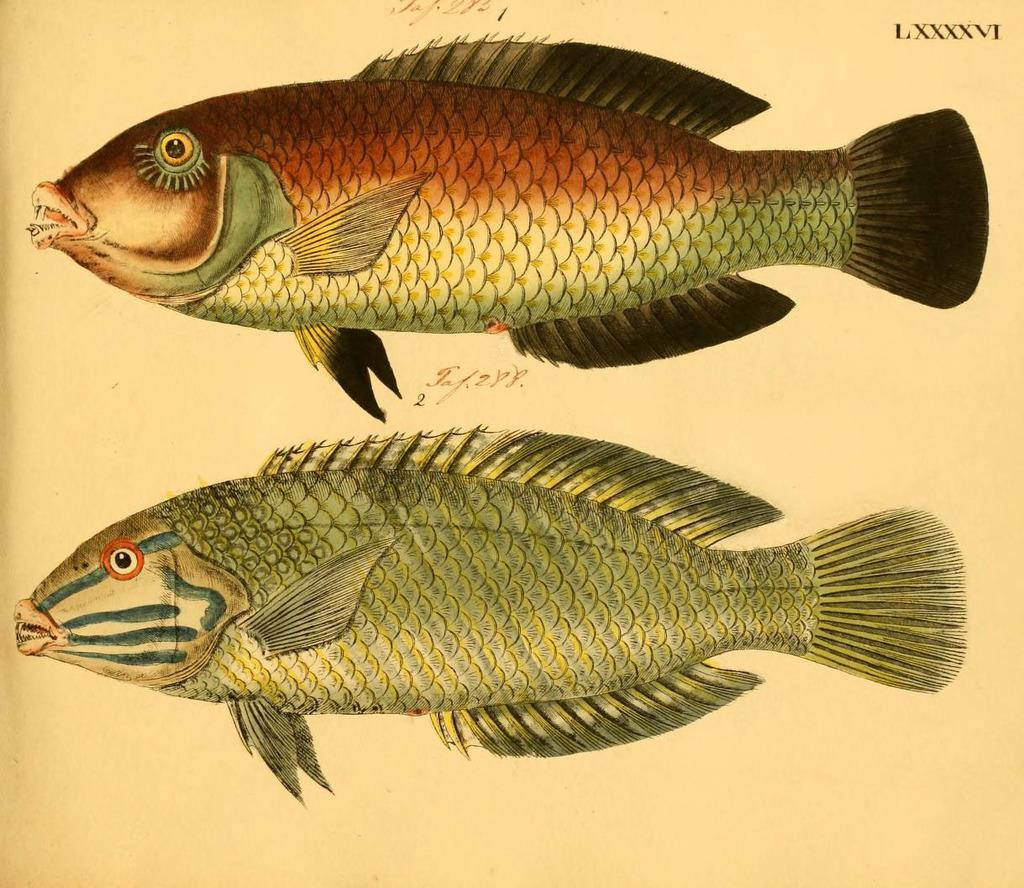What is depicted in the image? There is a sketch of two fishes in the image. Can you describe the fishes in the sketch? Unfortunately, the sketch does not provide enough detail to describe the appearance of the fishes. What might the purpose of this sketch be? It is unclear from the image alone what the purpose of the sketch is, but it could be a drawing, a study, or a design. How many holes can be seen in the sketch of the fishes? There are no holes visible in the sketch of the fishes; it is a two-dimensional drawing. 